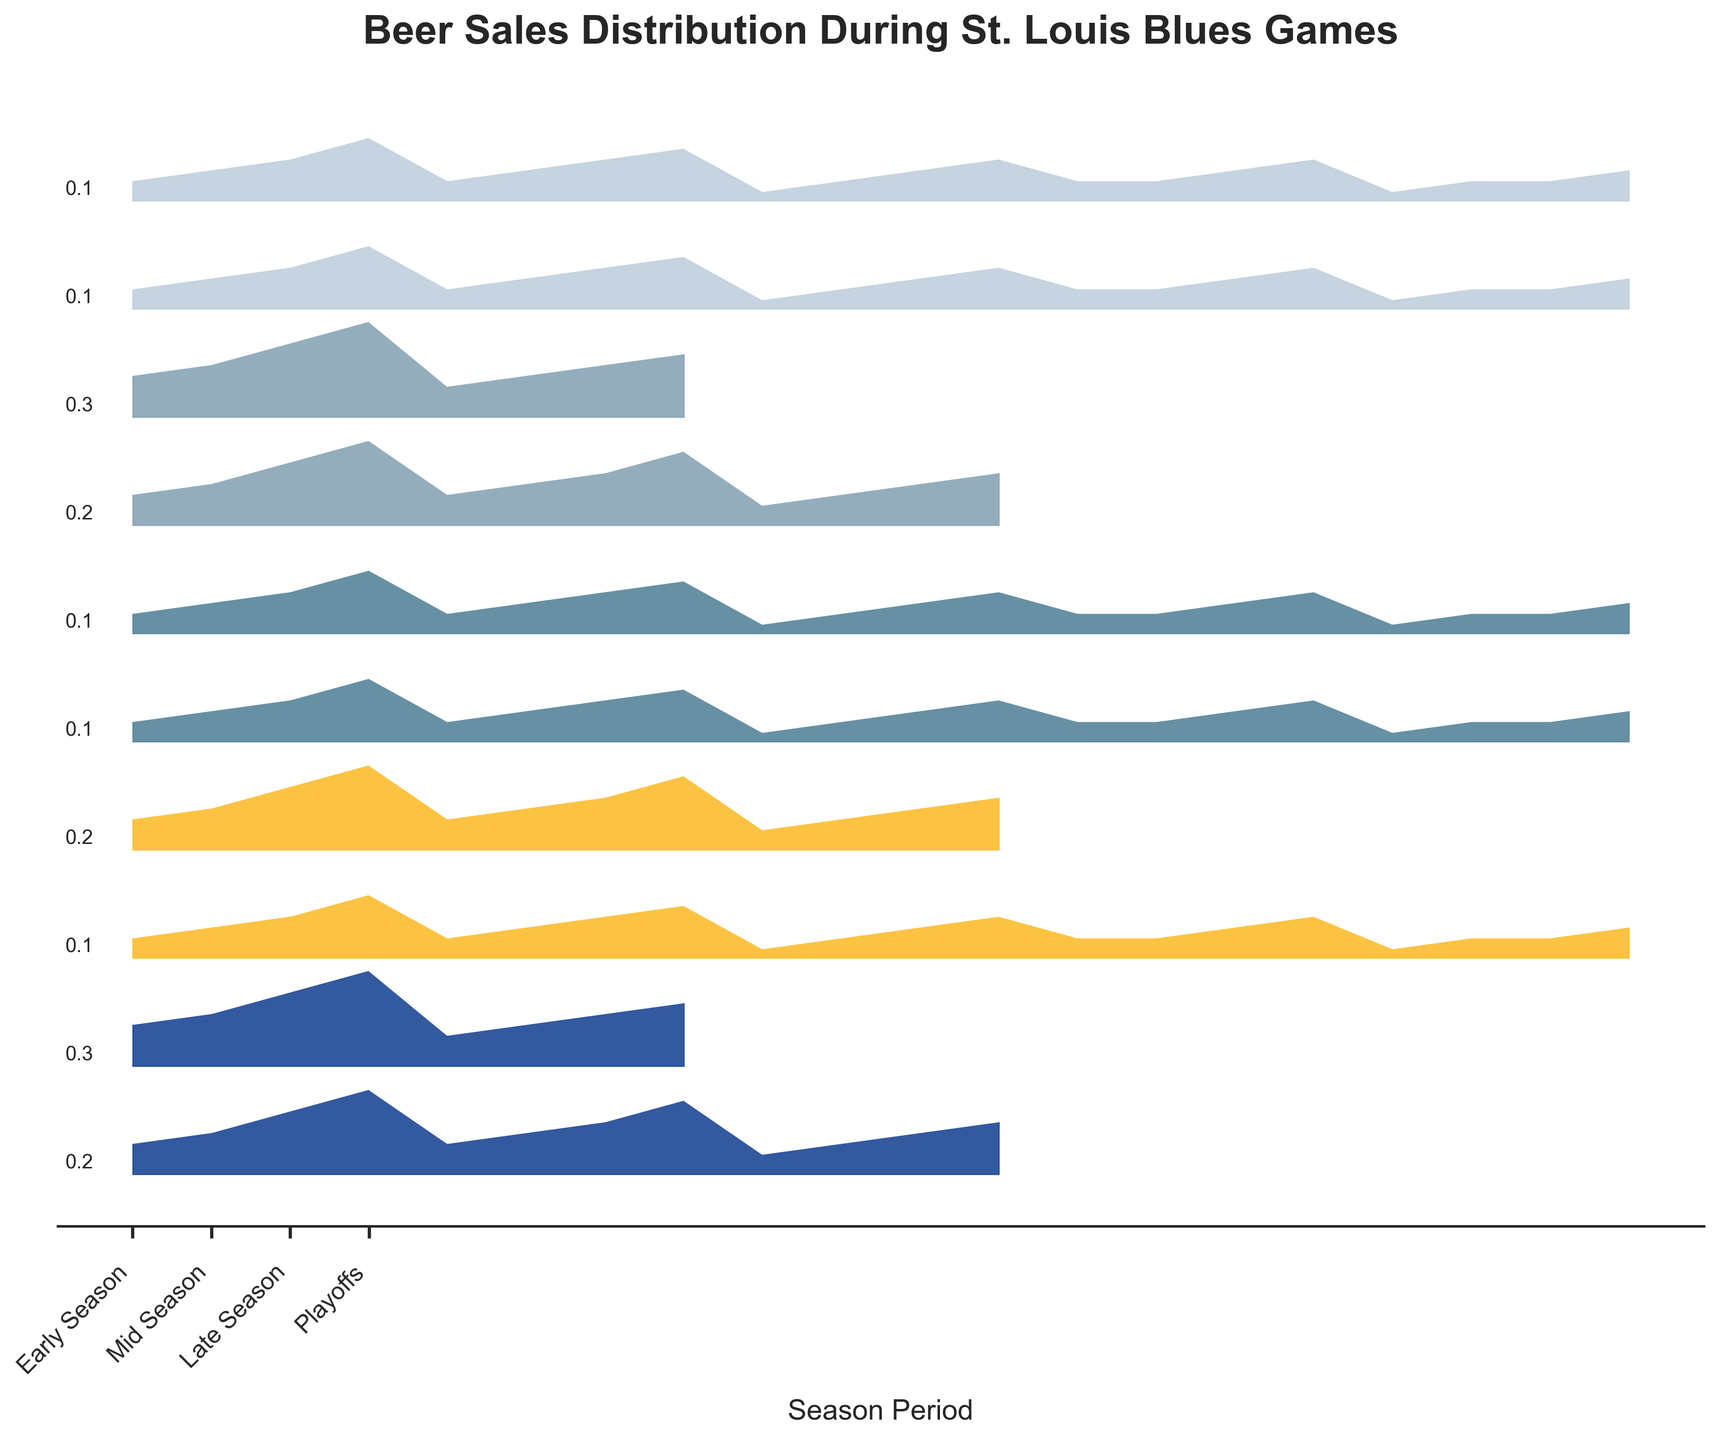What is the title of the plot? The title is typically displayed at the top of the figure in a larger and bolder font.
Answer: Beer Sales Distribution During St. Louis Blues Games Which beer has the highest sales during the Playoffs? By examining the height of the curves at the Playoffs period, the highest curve represents the beer with the highest sales.
Answer: Budweiser How do the sales of Shock Top compare between the Early Season and Mid Season? Compare the heights of the curves for Shock Top at Early Season and Mid Season. The curve for Early Season is lower than the curve for Mid Season.
Answer: Higher in Mid Season Which period of the season shows the most significant increase in sales for Bud Light? Compare the differences between successive periods for Bud Light. The largest difference is between Playoffs and Late Season.
Answer: Playoffs What is the trend in beer sales for Schlafly Pale Ale from Early Season to Playoffs? By following the height of the Schlafly Pale Ale curve from left to right, there's a consistent increase in height, indicating increasing sales.
Answer: Increasing Which two beers show the least variation in sales across the season periods? Identify the beers with the flattest curves, which indicate minimal change in height across all periods.
Answer: O'Fallon 5 Day IPA and Shock Top What is the average sales during the Playoffs for all beers combined? Sum the heights of all beers' curves at the Playoffs period and then divide by the number of beers.
Answer: 5.1/10 = 0.51 Comparing Mid Season and Playoffs, which beer shows the largest increase in sales? By calculating the difference in curve heights between Playoffs and Mid Season for each beer, Bud Light shows the largest increase.
Answer: Bud Light How does the sales distribution pattern change from Early Season to Late Season for Stella Artois? The curve height increases gradually from Early Season to Late Season, indicating an increase in sales over time.
Answer: Increasing Which period shows the least variation in sales among all beers? Compare the uniformity of curve heights for each period; the Early Season shows the least variation as the heights are more consistent.
Answer: Early Season 